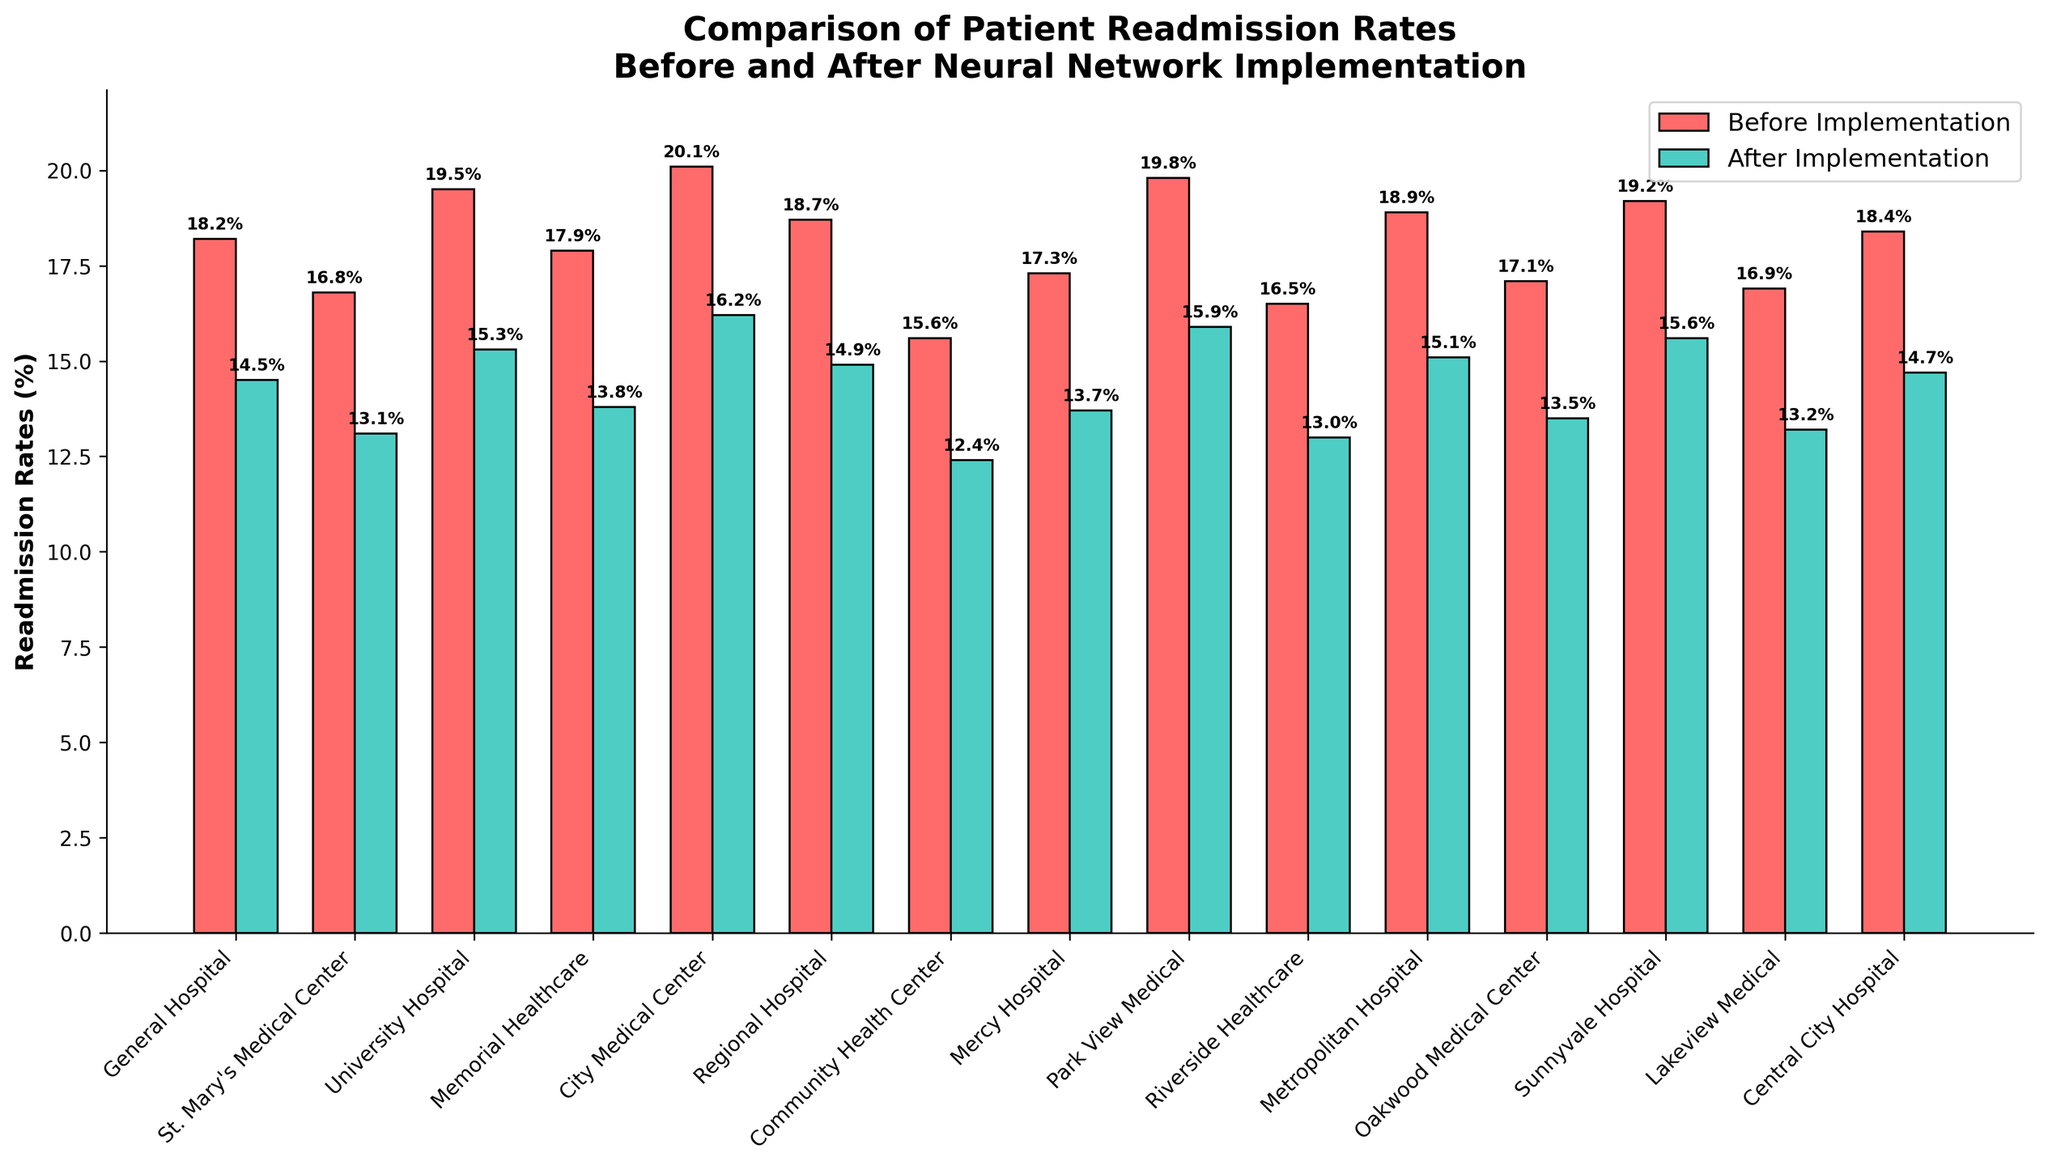What's the average readmission rate after implementation across all hospitals? To find the average readmission rate after implementation, sum up all the readmission rates after implementation and divide by the number of hospitals: (14.5 + 13.1 + 15.3 + 13.8 + 16.2 + 14.9 + 12.4 + 13.7 + 15.9 + 13.0 + 15.1 + 13.5 + 15.6 + 13.2 + 14.7) / 15 = 14.31%
Answer: 14.31% Which hospital had the greatest improvement in readmission rates after implementation? To find the greatest improvement, calculate the difference for each hospital between before and after implementation, and identify the highest value. Improvements: General Hospital: 3.7%, St. Mary's Medical Center: 3.7%, University Hospital: 4.2%, Memorial Healthcare: 4.1%, City Medical Center: 3.9%, Regional Hospital: 3.8%, Community Health Center: 3.2%, Mercy Hospital: 3.6%, Park View Medical: 3.9%, Riverside Healthcare: 3.5%, Metropolitan Hospital: 3.8%, Oakwood Medical Center: 3.6%, Sunnyvale Hospital: 3.6%, Lakeview Medical: 3.7%, Central City Hospital: 3.7%. University Hospital had the greatest reduction.
Answer: University Hospital How many hospitals had a readmission rate below 14% after implementation? Check the readmission rates after implementation for each hospital and count those below 14%: St. Mary's Medical Center (13.1%), Memorial Healthcare (13.8%), Community Health Center (12.4%), Mercy Hospital (13.7%), Riverside Healthcare (13.0%), Oakwood Medical Center (13.5%), Lakeview Medical (13.2%). There are 7 hospitals below 14%.
Answer: 7 What is the total decrease in readmission rate across all hospitals after implementation? Calculate the difference between the readmission rates before and after implementation for each hospital and sum them up: (3.7 + 3.7 + 4.2 + 4.1 + 3.9 + 3.8 + 3.2 + 3.6 + 3.9 + 3.5 + 3.8 + 3.6 + 3.6 + 3.7 + 3.7) = 54.0%. The total decrease is 54%.
Answer: 54% Which hospital had the smallest change in readmission rate after implementation? To find the smallest change, calculate the difference for each hospital between before and after implementation, and identify the lowest value: Community Health Center had the smallest reduction at 3.2%.
Answer: Community Health Center How did the readmission rate of Mercy Hospital compare to Oakwood Medical Center before and after implementation? Compare the readmission rates of both hospitals before and after implementation. Mercy Hospital: 17.3% to 13.7%, Oakwood Medical Center: 17.1% to 13.5%. Both hospitals had similar reductions: 3.6% each.
Answer: Similar reductions of 3.6% each Which hospital had the highest readmission rate before implementation, and what was its readmission rate after implementation? Identify the hospital with the highest readmission rate before implementation and compare it to its rate after implementation. City Medical Center had the highest rate before implementation at 20.1%. After implementation, it was 16.2%.
Answer: City Medical Center had 16.2% after What was the median readmission rate before implementation across all hospitals? Sort the readmission rates before implementation and find the middle value: Sorted readmission rates: 15.6, 16.5, 16.8, 16.9, 17.1, 17.3, 17.9, 18.2, 18.4, 18.7, 18.9, 19.2, 19.5, 19.8, 20.1. The median is the 8th value, which is 18.2%.
Answer: 18.2% By what percentage did the readmission rate decrease on average across all hospitals after implementation? Calculate the average change across all hospitals and express it as a percentage: Average change = [(3.7 + 3.7 + 4.2 + 4.1 + 3.9 + 3.8 + 3.2 + 3.6 + 3.9 + 3.5 + 3.8 + 3.6 + 3.6 + 3.7 + 3.7) / 15] = 3.6%. The average decrease is 3.6 percentage points.
Answer: 3.6% Which hospital's readmission rate showed the least improvement and what was the improvement? Calculate the difference for each hospital between before and after implementation, and identify the smallest improvement: Community Health Center had the least improvement with a 3.2% reduction.
Answer: Community Health Center, 3.2% 